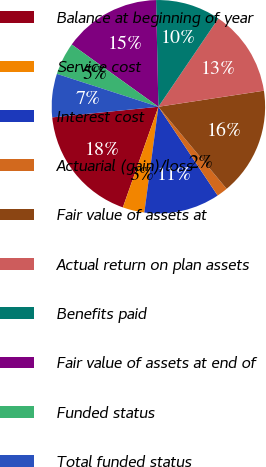Convert chart. <chart><loc_0><loc_0><loc_500><loc_500><pie_chart><fcel>Balance at beginning of year<fcel>Service cost<fcel>Interest cost<fcel>Actuarial (gain)/loss<fcel>Fair value of assets at<fcel>Actual return on plan assets<fcel>Benefits paid<fcel>Fair value of assets at end of<fcel>Funded status<fcel>Total funded status<nl><fcel>18.01%<fcel>3.3%<fcel>11.47%<fcel>1.67%<fcel>16.37%<fcel>13.1%<fcel>9.84%<fcel>14.74%<fcel>4.93%<fcel>6.57%<nl></chart> 